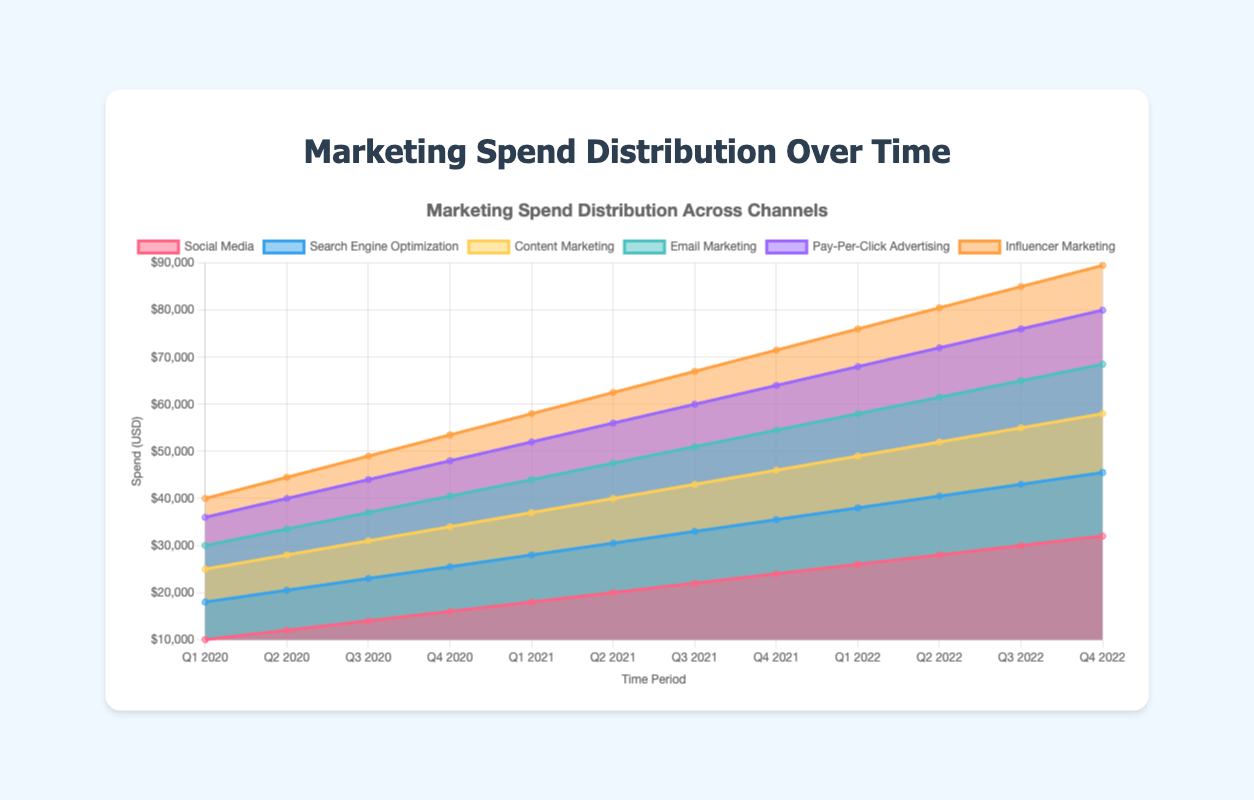What is the title of the chart? The title of the chart is displayed at the top and reads "Marketing Spend Distribution Across Channels".
Answer: Marketing Spend Distribution Across Channels How many time periods are displayed on the x-axis? By counting the labels on the x-axis from the figure, the number of time periods can be determined.
Answer: 12 Which marketing channel had the highest spend in Q4 2022? By observing the stacked layers in Q4 2022, we can see which channel has the highest value at the topmost point.
Answer: Social Media What is the total marketing spend in Q1 2021? To find the total spend for Q1 2021, sum the spend from all channels for that quarter: 18000 (Social Media) + 10000 (SEO) + 9000 (Content Marketing) + 7000 (Email Marketing) + 8000 (PPC) + 6000 (Influencer Marketing).
Answer: 58000 Which channel shows the most significant increase in spending from Q1 2020 to Q4 2022? To find the channel with the most significant increase, compare the difference between spending in Q1 2020 and Q4 2022 for each channel and see which has the largest increase.
Answer: Social Media How has the spend on Email Marketing changed from Q2 2021 to Q3 2022? Observe the Email Marketing values from Q2 2021 (7500) to Q3 2022 (10000), and calculate the percentage change: ((10000-7500)/7500) * 100%.
Answer: Increased by 33.33% During which quarter did Influencer Marketing spend reach 8000? By looking at the time periods along the x-axis where Influencer Marketing reaches 8000, it can be identified in the figure.
Answer: Q1 2022 What was the combined spending on Content Marketing and PPC Advertising in Q2 2022? Adding the spend of Content Marketing (11500) and PPC Advertising (10500) in Q2 2022 would provide the combined spending: 11500 + 10500.
Answer: 22000 Which channel had the least variation in spending over the entire time period from Q1 2020 to Q4 2022? By visually inspecting the changes in each channel's area over the time periods, we find that Search Engine Optimization (SEO) shows the least variation.
Answer: Search Engine Optimization (SEO) In which quarter did Social Media spending first exceed 20000? Identify the first quarter where the spending data point for Social Media surpasses 20000 directly on the chart.
Answer: Q2 2021 